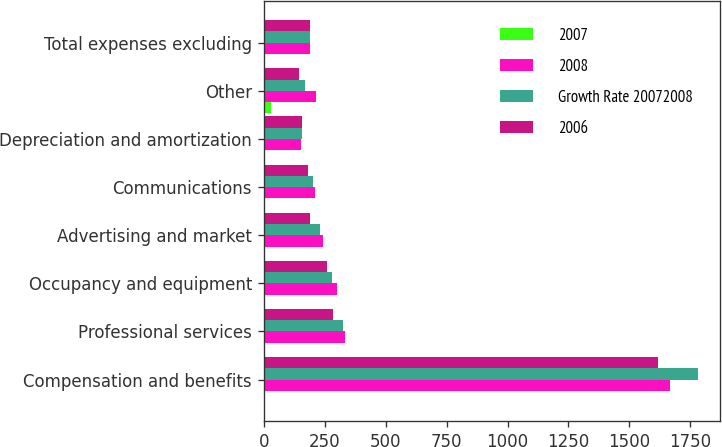Convert chart to OTSL. <chart><loc_0><loc_0><loc_500><loc_500><stacked_bar_chart><ecel><fcel>Compensation and benefits<fcel>Professional services<fcel>Occupancy and equipment<fcel>Advertising and market<fcel>Communications<fcel>Depreciation and amortization<fcel>Other<fcel>Total expenses excluding<nl><fcel>2007<fcel>6<fcel>3<fcel>6<fcel>6<fcel>6<fcel>3<fcel>29<fcel>1<nl><fcel>2008<fcel>1667<fcel>334<fcel>299<fcel>243<fcel>211<fcel>152<fcel>216<fcel>189<nl><fcel>Growth Rate 20072008<fcel>1781<fcel>324<fcel>282<fcel>230<fcel>200<fcel>156<fcel>168<fcel>189<nl><fcel>2006<fcel>1619<fcel>285<fcel>260<fcel>189<fcel>180<fcel>157<fcel>143<fcel>189<nl></chart> 